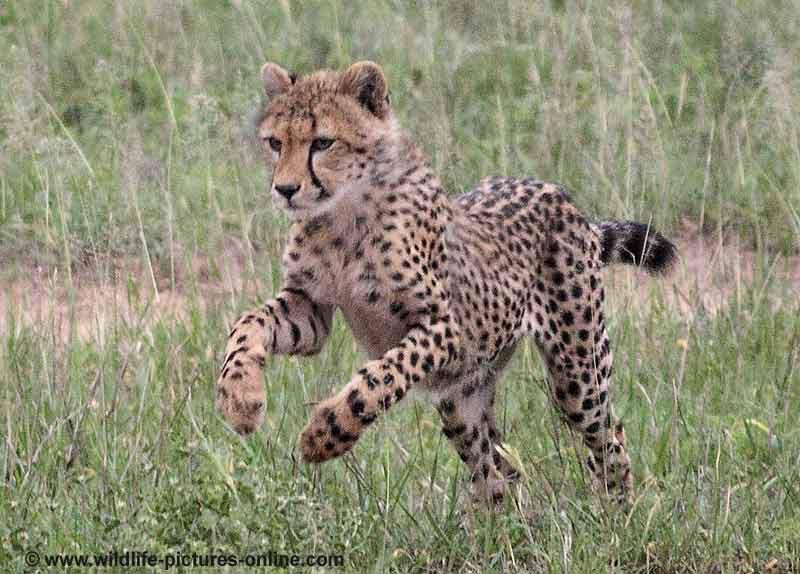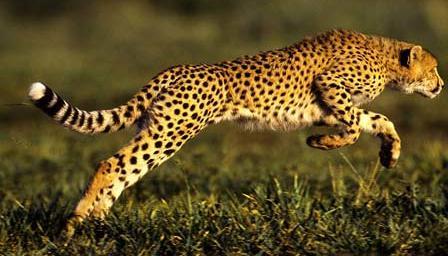The first image is the image on the left, the second image is the image on the right. Examine the images to the left and right. Is the description "the left and right image contains the same number of cheetahs jumping in the air." accurate? Answer yes or no. Yes. The first image is the image on the left, the second image is the image on the right. Assess this claim about the two images: "Each image contains exactly one cheetah, and each of the cheetahs depicted is in a bounding pose, with at least both front paws off the ground.". Correct or not? Answer yes or no. Yes. 